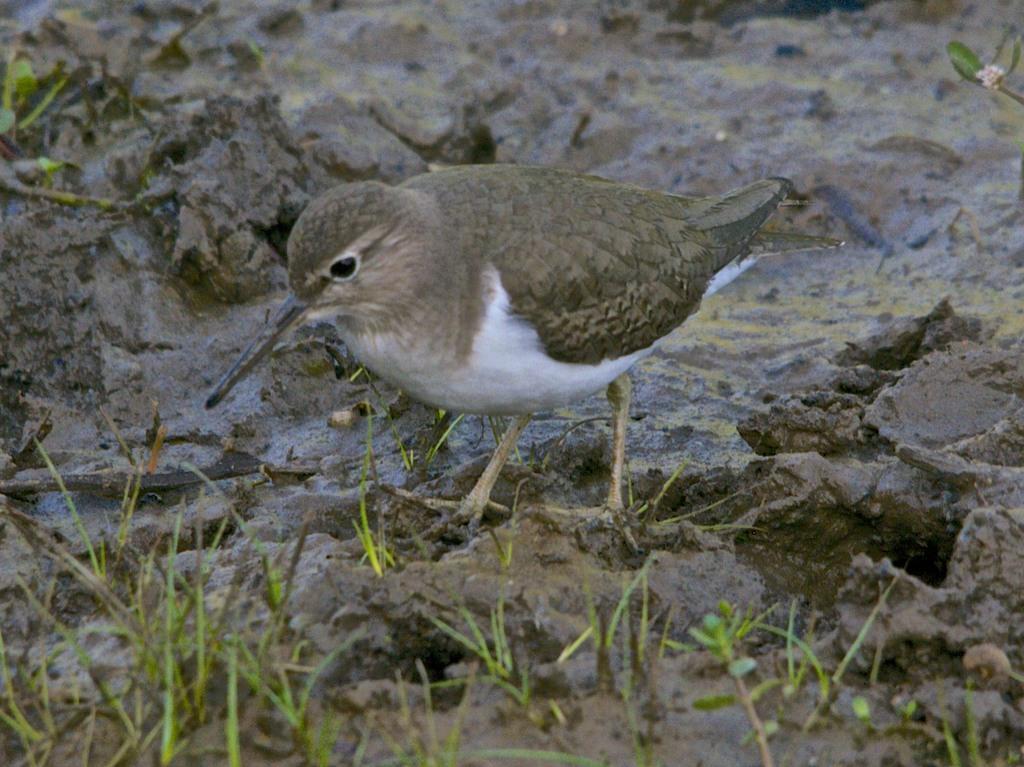Could you give a brief overview of what you see in this image? At the bottom of the picture, we see the grass and the mud. In the middle, we see a bird in grey and white color. It has a long beak. 